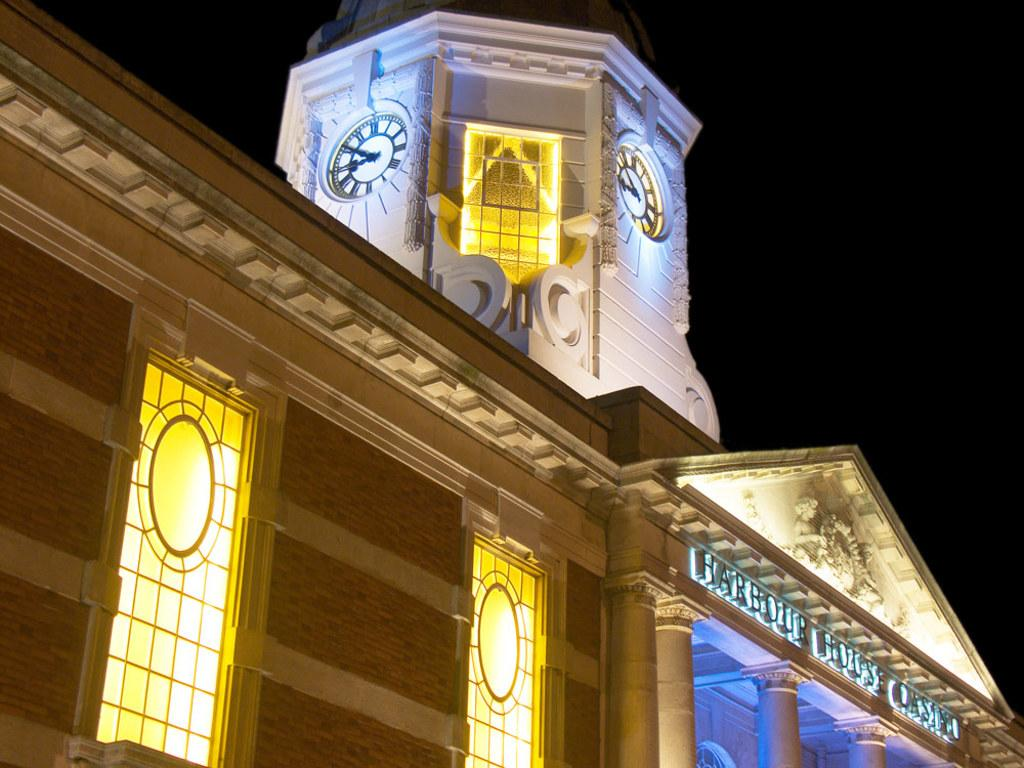What type of structure is present in the image? There is a building in the image. What features can be seen on the building? The building has clocks and sculptures. What can be seen in the background of the image? The sky is visible in the background of the image. Is there a coat hanging on the sculpture in the image? There is no coat present in the image; the image only shows a building with clocks and sculptures. 